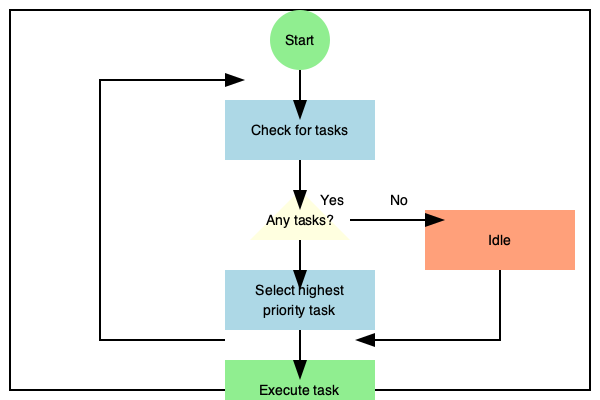In the given flowchart of a real-time operating system scheduler for embedded systems, what critical step is missing that ensures the scheduler maintains system responsiveness and prevents task starvation? To answer this question, let's analyze the flowchart step-by-step:

1. The flowchart starts with checking for tasks.
2. If tasks are available, it selects the highest priority task.
3. The selected task is then executed.
4. If no tasks are available, the system goes into an idle state.
5. After task execution or idle state, the process loops back to checking for tasks.

While this flowchart covers the basic operations of a real-time operating system scheduler, it's missing a critical step that ensures system responsiveness and prevents task starvation. This missing step is time slicing or preemption.

In a real-time operating system, especially for embedded systems, it's crucial to:

a) Maintain responsiveness to high-priority events
b) Prevent lower-priority tasks from being starved of CPU time

Time slicing or preemption addresses these issues by:

1. Interrupting the currently executing task after a predefined time interval (time slice)
2. Allowing the scheduler to re-evaluate task priorities
3. Potentially switching to a higher priority task that may have become ready

Without this step, a long-running, high-priority task could monopolize the CPU, leading to poor system responsiveness and potential deadline misses for other critical tasks.

The missing step should be inserted between the "Execute task" and the loop back to "Check for tasks". It would typically involve:

1. Checking if the current time slice has expired
2. If expired, saving the context of the current task
3. Re-evaluating task priorities
4. Potentially switching to a different task

This mechanism ensures that even if a high-priority task is running, the scheduler regularly gets control to make decisions based on the current system state, maintaining real-time responsiveness.
Answer: Time slicing or preemption 